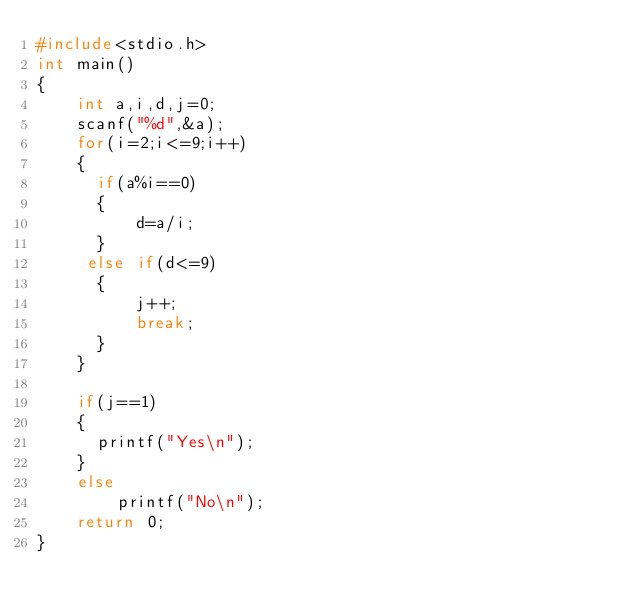<code> <loc_0><loc_0><loc_500><loc_500><_C_>#include<stdio.h>
int main()
{
    int a,i,d,j=0;
    scanf("%d",&a);
    for(i=2;i<=9;i++)
    {
      if(a%i==0)
      {
          d=a/i;
      }
     else if(d<=9)
      {
          j++;
          break;
      }
    }

    if(j==1)
    {
      printf("Yes\n");
    }
    else
        printf("No\n");
    return 0;
}
</code> 